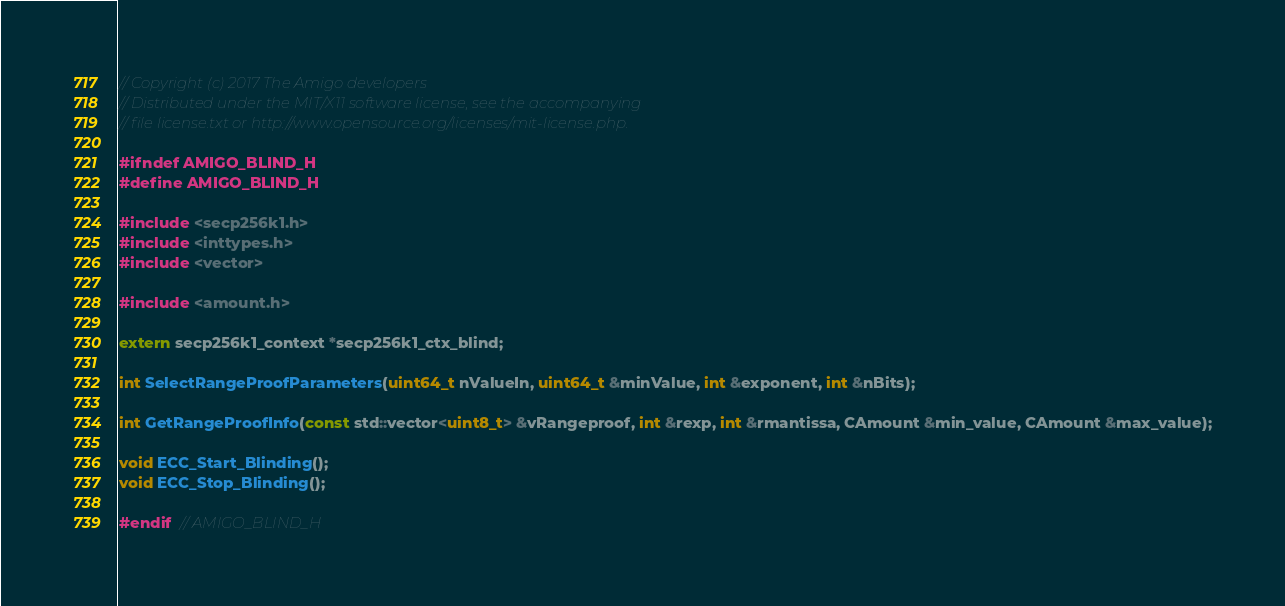<code> <loc_0><loc_0><loc_500><loc_500><_C_>// Copyright (c) 2017 The Amigo developers
// Distributed under the MIT/X11 software license, see the accompanying
// file license.txt or http://www.opensource.org/licenses/mit-license.php.

#ifndef AMIGO_BLIND_H
#define AMIGO_BLIND_H

#include <secp256k1.h>
#include <inttypes.h>
#include <vector>

#include <amount.h>

extern secp256k1_context *secp256k1_ctx_blind;

int SelectRangeProofParameters(uint64_t nValueIn, uint64_t &minValue, int &exponent, int &nBits);

int GetRangeProofInfo(const std::vector<uint8_t> &vRangeproof, int &rexp, int &rmantissa, CAmount &min_value, CAmount &max_value);

void ECC_Start_Blinding();
void ECC_Stop_Blinding();

#endif  // AMIGO_BLIND_H
</code> 